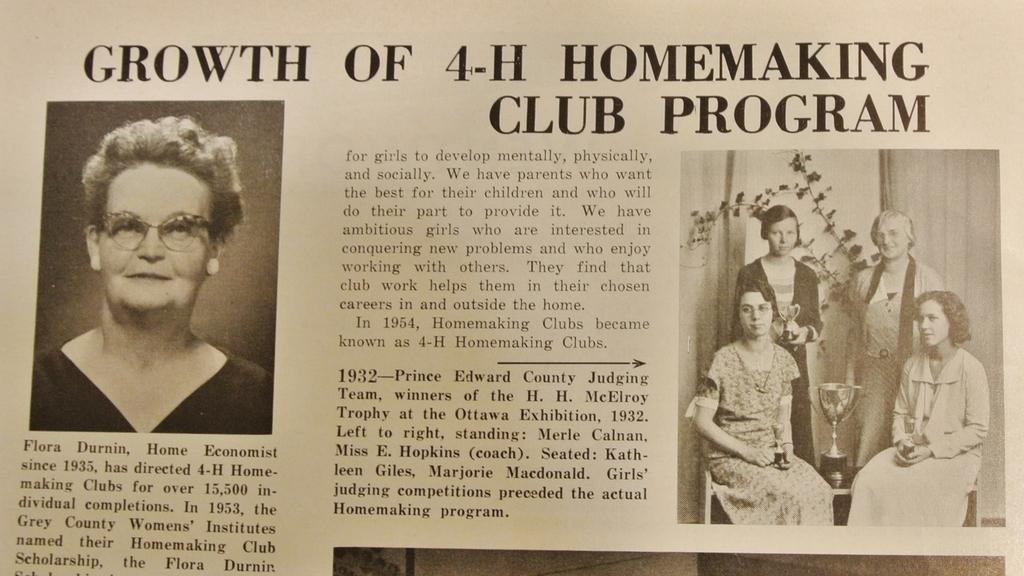What is depicted on the left side of the image? There is a black and white picture of a woman on the left side of the image. How many women are on the right side of the image? There are four women on the right side of the image. What can be found in the middle of the image? There is text in the middle of the image. What type of soap is being used by the women on the right side of the image? There is no soap present in the image; it features a black and white picture of a woman and four women on the right side, along with text in the middle. What color is the spark emitted by the badge on the left side of the image? There is no badge or spark present in the image. 